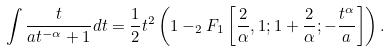<formula> <loc_0><loc_0><loc_500><loc_500>\int \frac { t } { a t ^ { - \alpha } + 1 } d t = \frac { 1 } { 2 } t ^ { 2 } \left ( 1 - _ { 2 } F _ { 1 } \left [ \frac { 2 } { \alpha } , 1 ; 1 + \frac { 2 } { \alpha } ; - \frac { t ^ { \alpha } } { a } \right ] \right ) .</formula> 